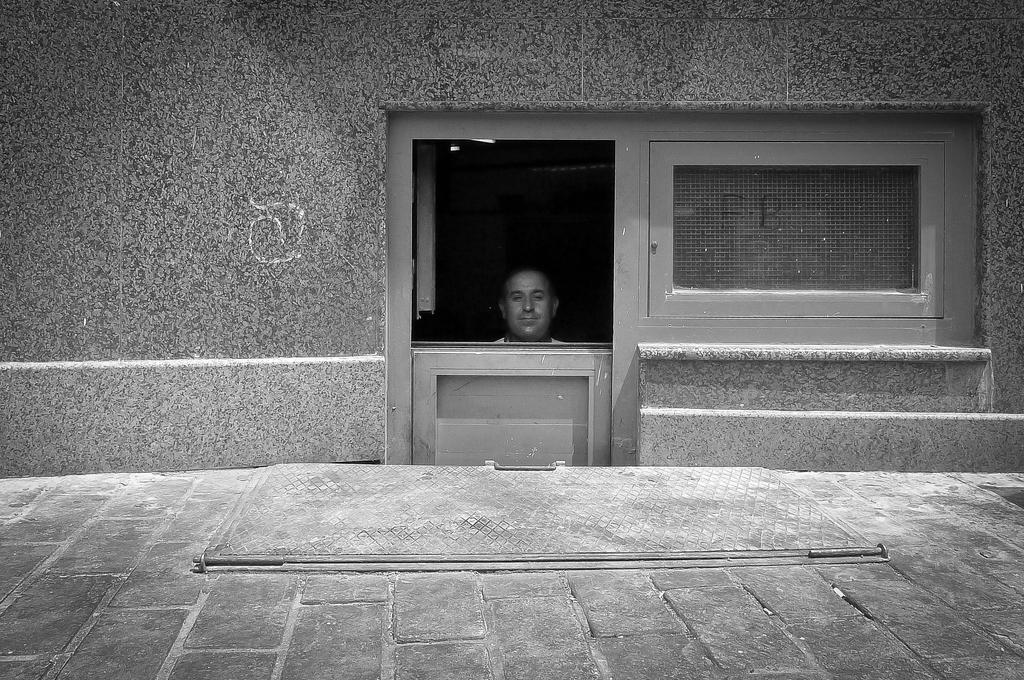What type of structure is visible in the image? There is a house in the image. What architectural feature can be seen on the house? There are windows in the image. Are there any people present in the image? Yes, there is a person in the image. Can you see any corn growing near the house in the image? There is no corn visible in the image. 